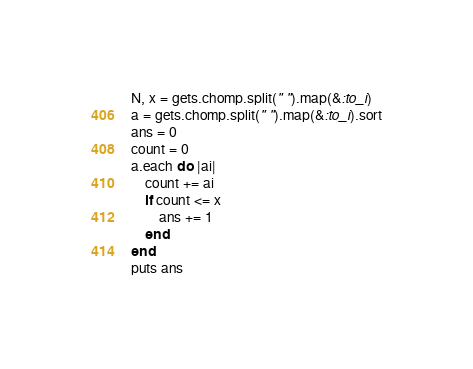Convert code to text. <code><loc_0><loc_0><loc_500><loc_500><_Ruby_>N, x = gets.chomp.split(" ").map(&:to_i)
a = gets.chomp.split(" ").map(&:to_i).sort
ans = 0
count = 0
a.each do |ai|
    count += ai
    if count <= x
        ans += 1
    end
end
puts ans</code> 